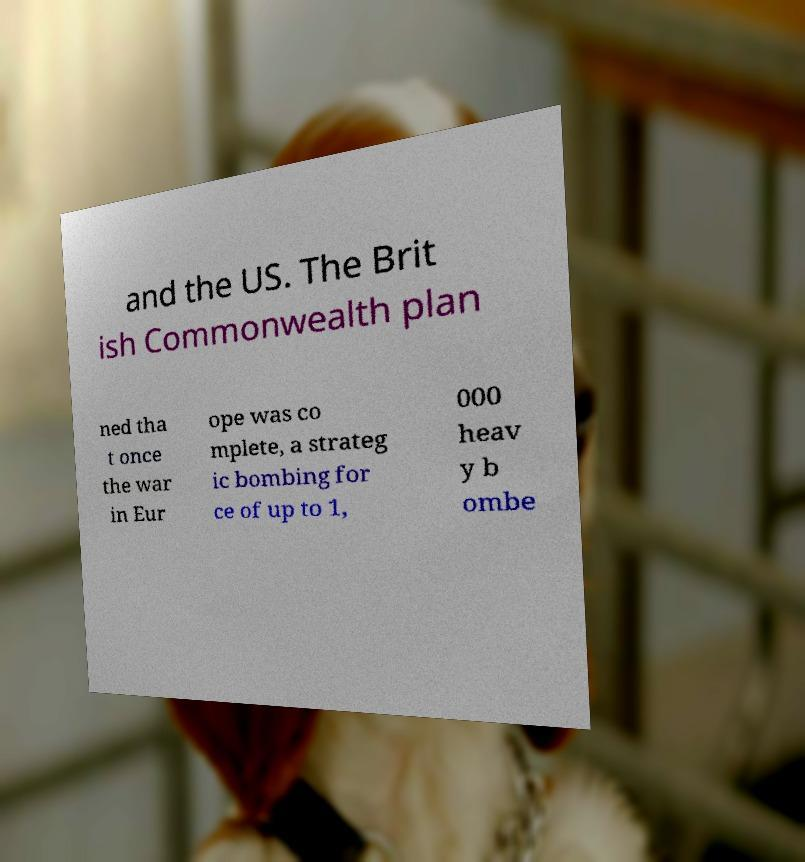Could you extract and type out the text from this image? and the US. The Brit ish Commonwealth plan ned tha t once the war in Eur ope was co mplete, a strateg ic bombing for ce of up to 1, 000 heav y b ombe 